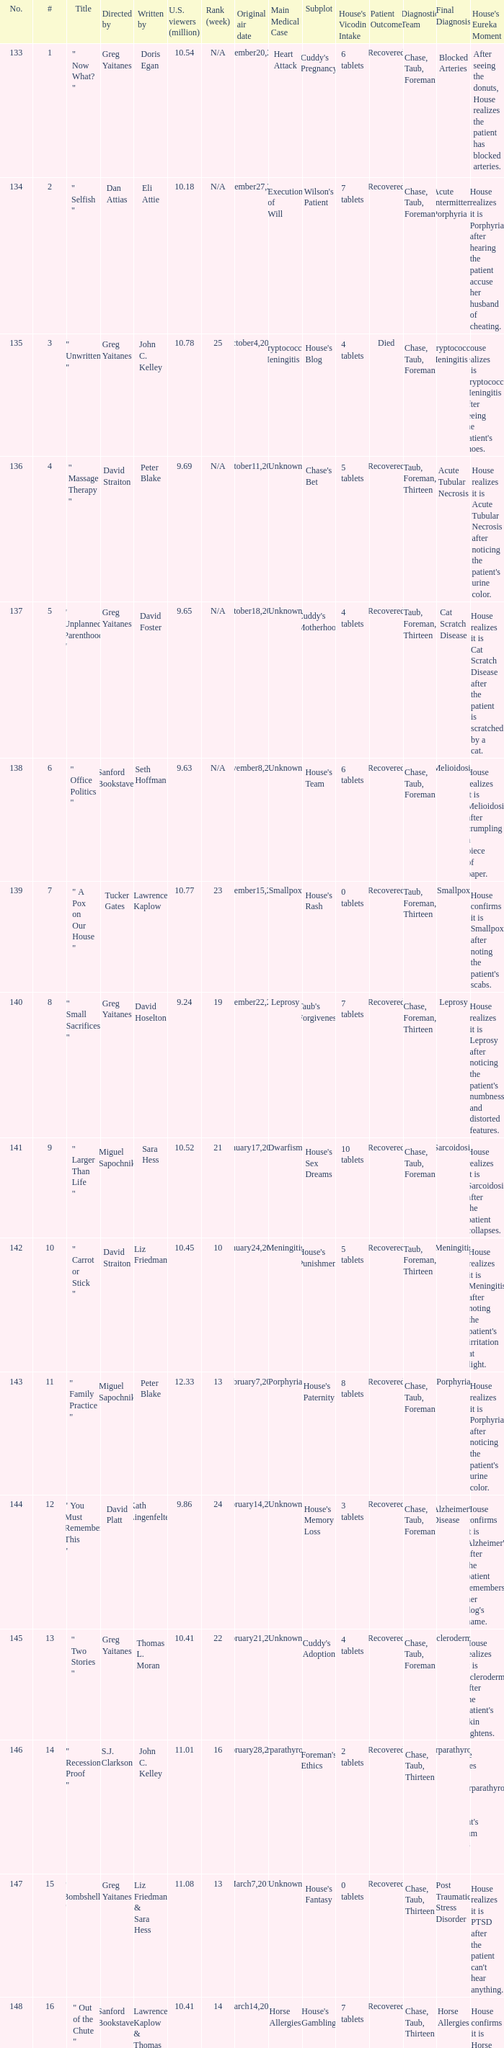How many episodes were written by seth hoffman, russel friend & garrett lerner? 1.0. 